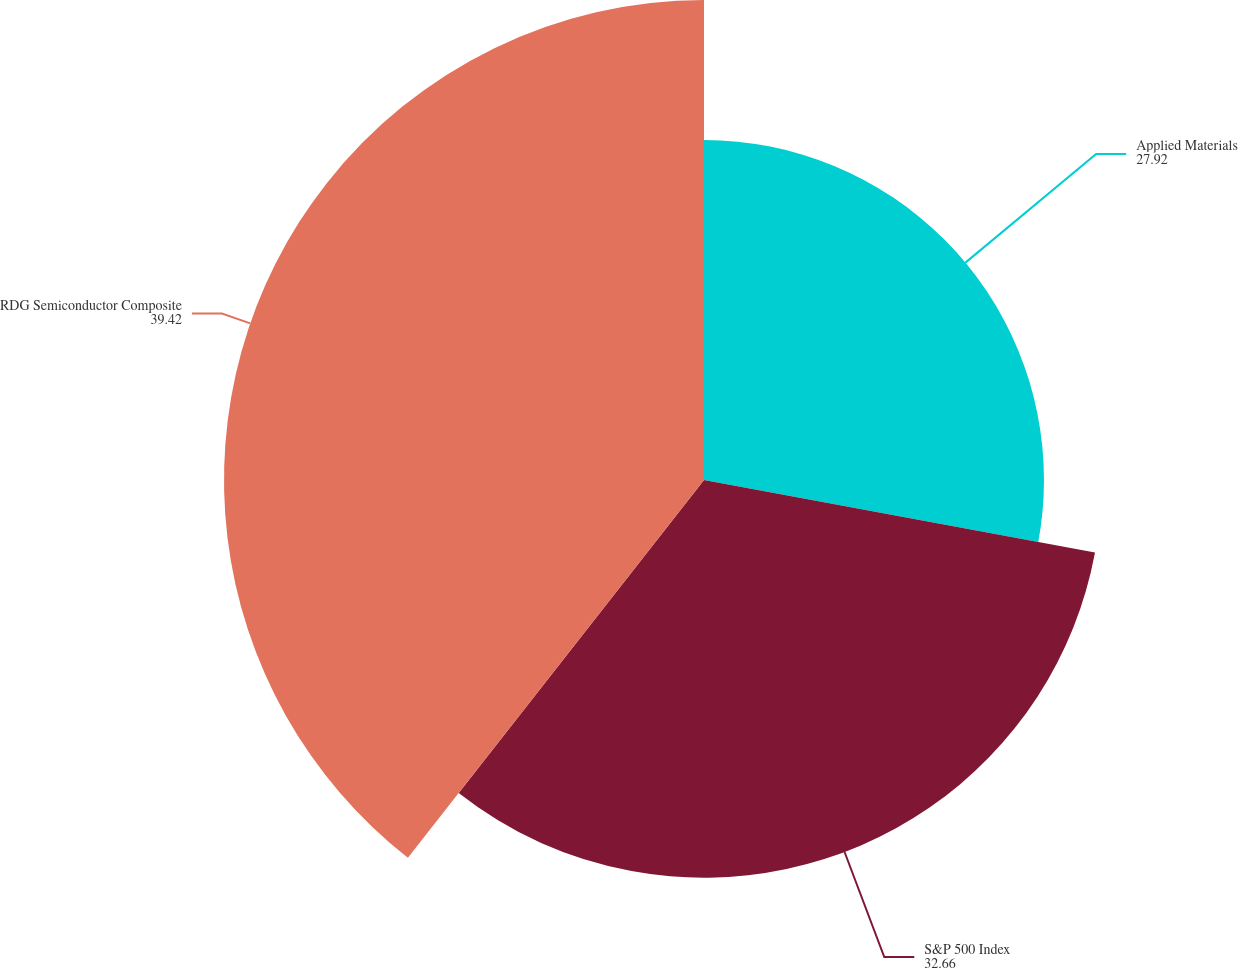Convert chart to OTSL. <chart><loc_0><loc_0><loc_500><loc_500><pie_chart><fcel>Applied Materials<fcel>S&P 500 Index<fcel>RDG Semiconductor Composite<nl><fcel>27.92%<fcel>32.66%<fcel>39.42%<nl></chart> 